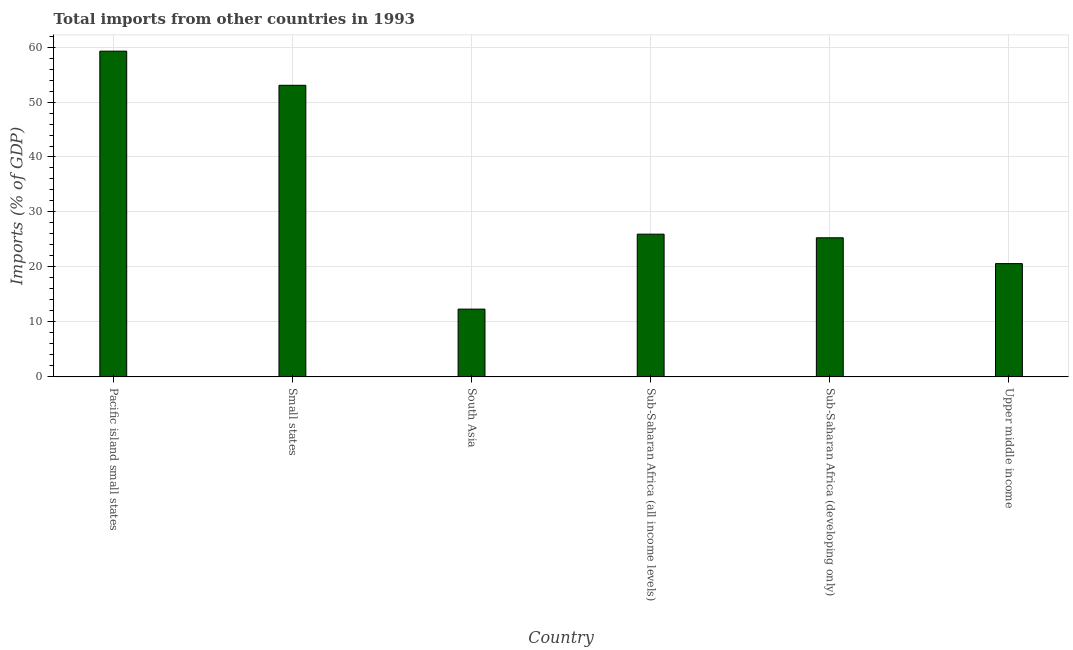Does the graph contain grids?
Provide a short and direct response. Yes. What is the title of the graph?
Keep it short and to the point. Total imports from other countries in 1993. What is the label or title of the X-axis?
Provide a succinct answer. Country. What is the label or title of the Y-axis?
Give a very brief answer. Imports (% of GDP). What is the total imports in Sub-Saharan Africa (developing only)?
Keep it short and to the point. 25.3. Across all countries, what is the maximum total imports?
Your response must be concise. 59.25. Across all countries, what is the minimum total imports?
Your response must be concise. 12.32. In which country was the total imports maximum?
Make the answer very short. Pacific island small states. In which country was the total imports minimum?
Offer a terse response. South Asia. What is the sum of the total imports?
Your response must be concise. 196.49. What is the difference between the total imports in South Asia and Upper middle income?
Keep it short and to the point. -8.28. What is the average total imports per country?
Make the answer very short. 32.75. What is the median total imports?
Ensure brevity in your answer.  25.63. What is the ratio of the total imports in Pacific island small states to that in Small states?
Your answer should be very brief. 1.12. Is the total imports in Pacific island small states less than that in Sub-Saharan Africa (all income levels)?
Provide a succinct answer. No. What is the difference between the highest and the second highest total imports?
Offer a terse response. 6.21. What is the difference between the highest and the lowest total imports?
Your answer should be very brief. 46.93. In how many countries, is the total imports greater than the average total imports taken over all countries?
Offer a very short reply. 2. How many countries are there in the graph?
Provide a short and direct response. 6. What is the difference between two consecutive major ticks on the Y-axis?
Provide a succinct answer. 10. Are the values on the major ticks of Y-axis written in scientific E-notation?
Make the answer very short. No. What is the Imports (% of GDP) of Pacific island small states?
Provide a short and direct response. 59.25. What is the Imports (% of GDP) of Small states?
Provide a short and direct response. 53.04. What is the Imports (% of GDP) in South Asia?
Give a very brief answer. 12.32. What is the Imports (% of GDP) of Sub-Saharan Africa (all income levels)?
Offer a terse response. 25.96. What is the Imports (% of GDP) of Sub-Saharan Africa (developing only)?
Your answer should be compact. 25.3. What is the Imports (% of GDP) in Upper middle income?
Offer a very short reply. 20.6. What is the difference between the Imports (% of GDP) in Pacific island small states and Small states?
Your response must be concise. 6.21. What is the difference between the Imports (% of GDP) in Pacific island small states and South Asia?
Your response must be concise. 46.93. What is the difference between the Imports (% of GDP) in Pacific island small states and Sub-Saharan Africa (all income levels)?
Ensure brevity in your answer.  33.29. What is the difference between the Imports (% of GDP) in Pacific island small states and Sub-Saharan Africa (developing only)?
Give a very brief answer. 33.95. What is the difference between the Imports (% of GDP) in Pacific island small states and Upper middle income?
Give a very brief answer. 38.65. What is the difference between the Imports (% of GDP) in Small states and South Asia?
Offer a very short reply. 40.72. What is the difference between the Imports (% of GDP) in Small states and Sub-Saharan Africa (all income levels)?
Provide a short and direct response. 27.08. What is the difference between the Imports (% of GDP) in Small states and Sub-Saharan Africa (developing only)?
Offer a terse response. 27.74. What is the difference between the Imports (% of GDP) in Small states and Upper middle income?
Your answer should be compact. 32.44. What is the difference between the Imports (% of GDP) in South Asia and Sub-Saharan Africa (all income levels)?
Ensure brevity in your answer.  -13.64. What is the difference between the Imports (% of GDP) in South Asia and Sub-Saharan Africa (developing only)?
Offer a terse response. -12.98. What is the difference between the Imports (% of GDP) in South Asia and Upper middle income?
Your answer should be compact. -8.28. What is the difference between the Imports (% of GDP) in Sub-Saharan Africa (all income levels) and Sub-Saharan Africa (developing only)?
Your answer should be very brief. 0.66. What is the difference between the Imports (% of GDP) in Sub-Saharan Africa (all income levels) and Upper middle income?
Provide a short and direct response. 5.36. What is the difference between the Imports (% of GDP) in Sub-Saharan Africa (developing only) and Upper middle income?
Make the answer very short. 4.7. What is the ratio of the Imports (% of GDP) in Pacific island small states to that in Small states?
Offer a terse response. 1.12. What is the ratio of the Imports (% of GDP) in Pacific island small states to that in South Asia?
Provide a short and direct response. 4.81. What is the ratio of the Imports (% of GDP) in Pacific island small states to that in Sub-Saharan Africa (all income levels)?
Your response must be concise. 2.28. What is the ratio of the Imports (% of GDP) in Pacific island small states to that in Sub-Saharan Africa (developing only)?
Your answer should be very brief. 2.34. What is the ratio of the Imports (% of GDP) in Pacific island small states to that in Upper middle income?
Provide a short and direct response. 2.88. What is the ratio of the Imports (% of GDP) in Small states to that in South Asia?
Your response must be concise. 4.3. What is the ratio of the Imports (% of GDP) in Small states to that in Sub-Saharan Africa (all income levels)?
Make the answer very short. 2.04. What is the ratio of the Imports (% of GDP) in Small states to that in Sub-Saharan Africa (developing only)?
Provide a succinct answer. 2.1. What is the ratio of the Imports (% of GDP) in Small states to that in Upper middle income?
Your answer should be very brief. 2.57. What is the ratio of the Imports (% of GDP) in South Asia to that in Sub-Saharan Africa (all income levels)?
Offer a very short reply. 0.47. What is the ratio of the Imports (% of GDP) in South Asia to that in Sub-Saharan Africa (developing only)?
Your answer should be compact. 0.49. What is the ratio of the Imports (% of GDP) in South Asia to that in Upper middle income?
Give a very brief answer. 0.6. What is the ratio of the Imports (% of GDP) in Sub-Saharan Africa (all income levels) to that in Sub-Saharan Africa (developing only)?
Offer a terse response. 1.03. What is the ratio of the Imports (% of GDP) in Sub-Saharan Africa (all income levels) to that in Upper middle income?
Provide a short and direct response. 1.26. What is the ratio of the Imports (% of GDP) in Sub-Saharan Africa (developing only) to that in Upper middle income?
Your answer should be compact. 1.23. 